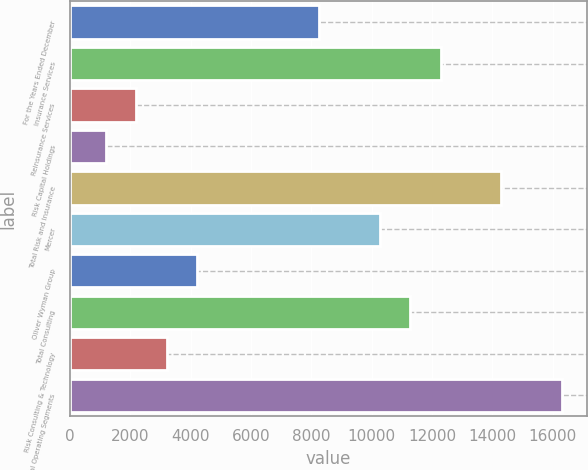<chart> <loc_0><loc_0><loc_500><loc_500><bar_chart><fcel>For the Years Ended December<fcel>Insurance Services<fcel>Reinsurance Services<fcel>Risk Capital Holdings<fcel>Total Risk and Insurance<fcel>Mercer<fcel>Oliver Wyman Group<fcel>Total Consulting<fcel>Risk Consulting & Technology<fcel>Total Operating Segments<nl><fcel>8249.6<fcel>12282.4<fcel>2200.4<fcel>1192.2<fcel>14298.8<fcel>10266<fcel>4216.8<fcel>11274.2<fcel>3208.6<fcel>16315.2<nl></chart> 